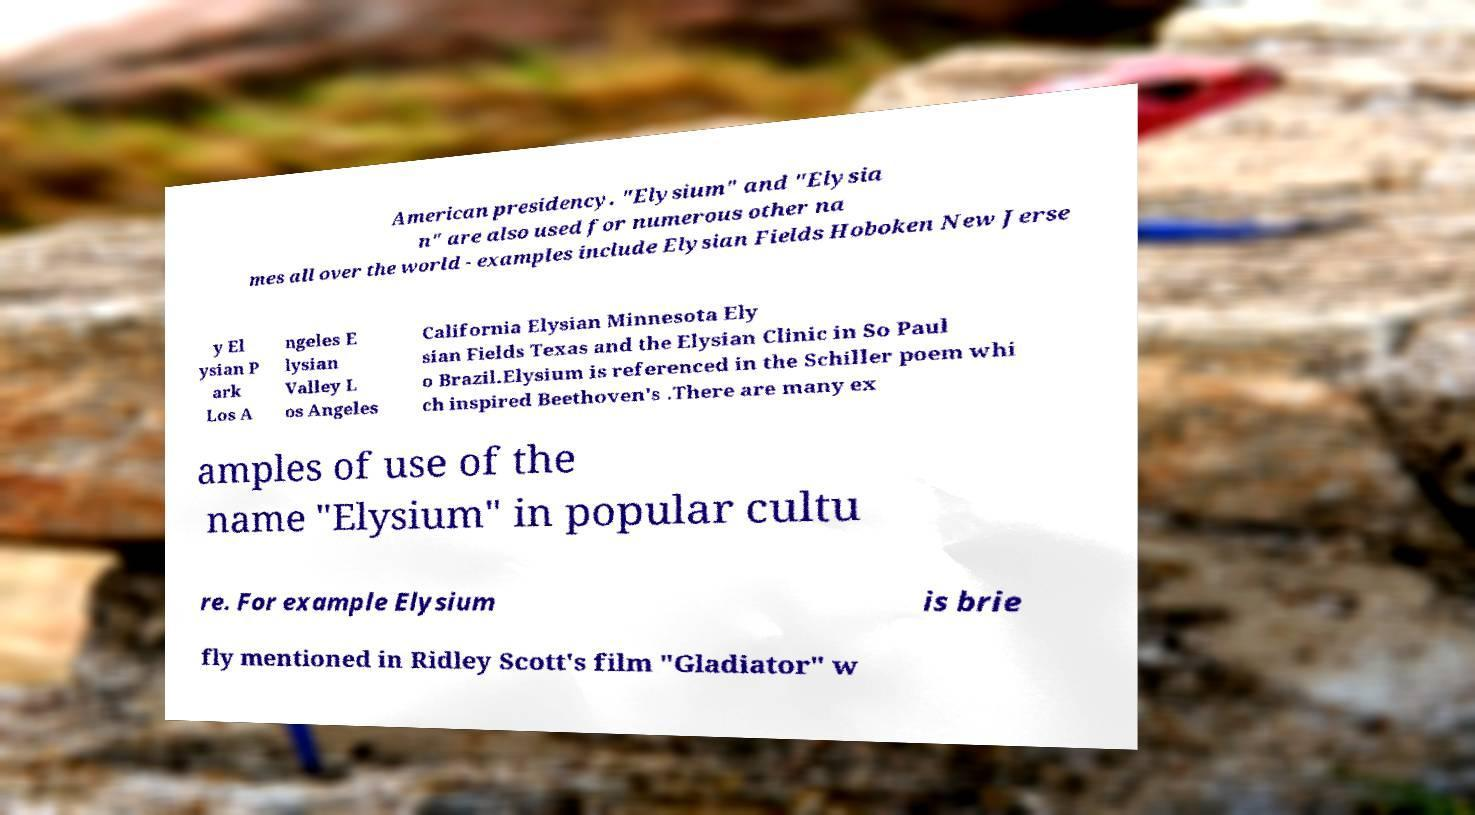For documentation purposes, I need the text within this image transcribed. Could you provide that? American presidency. "Elysium" and "Elysia n" are also used for numerous other na mes all over the world - examples include Elysian Fields Hoboken New Jerse y El ysian P ark Los A ngeles E lysian Valley L os Angeles California Elysian Minnesota Ely sian Fields Texas and the Elysian Clinic in So Paul o Brazil.Elysium is referenced in the Schiller poem whi ch inspired Beethoven's .There are many ex amples of use of the name "Elysium" in popular cultu re. For example Elysium is brie fly mentioned in Ridley Scott's film "Gladiator" w 